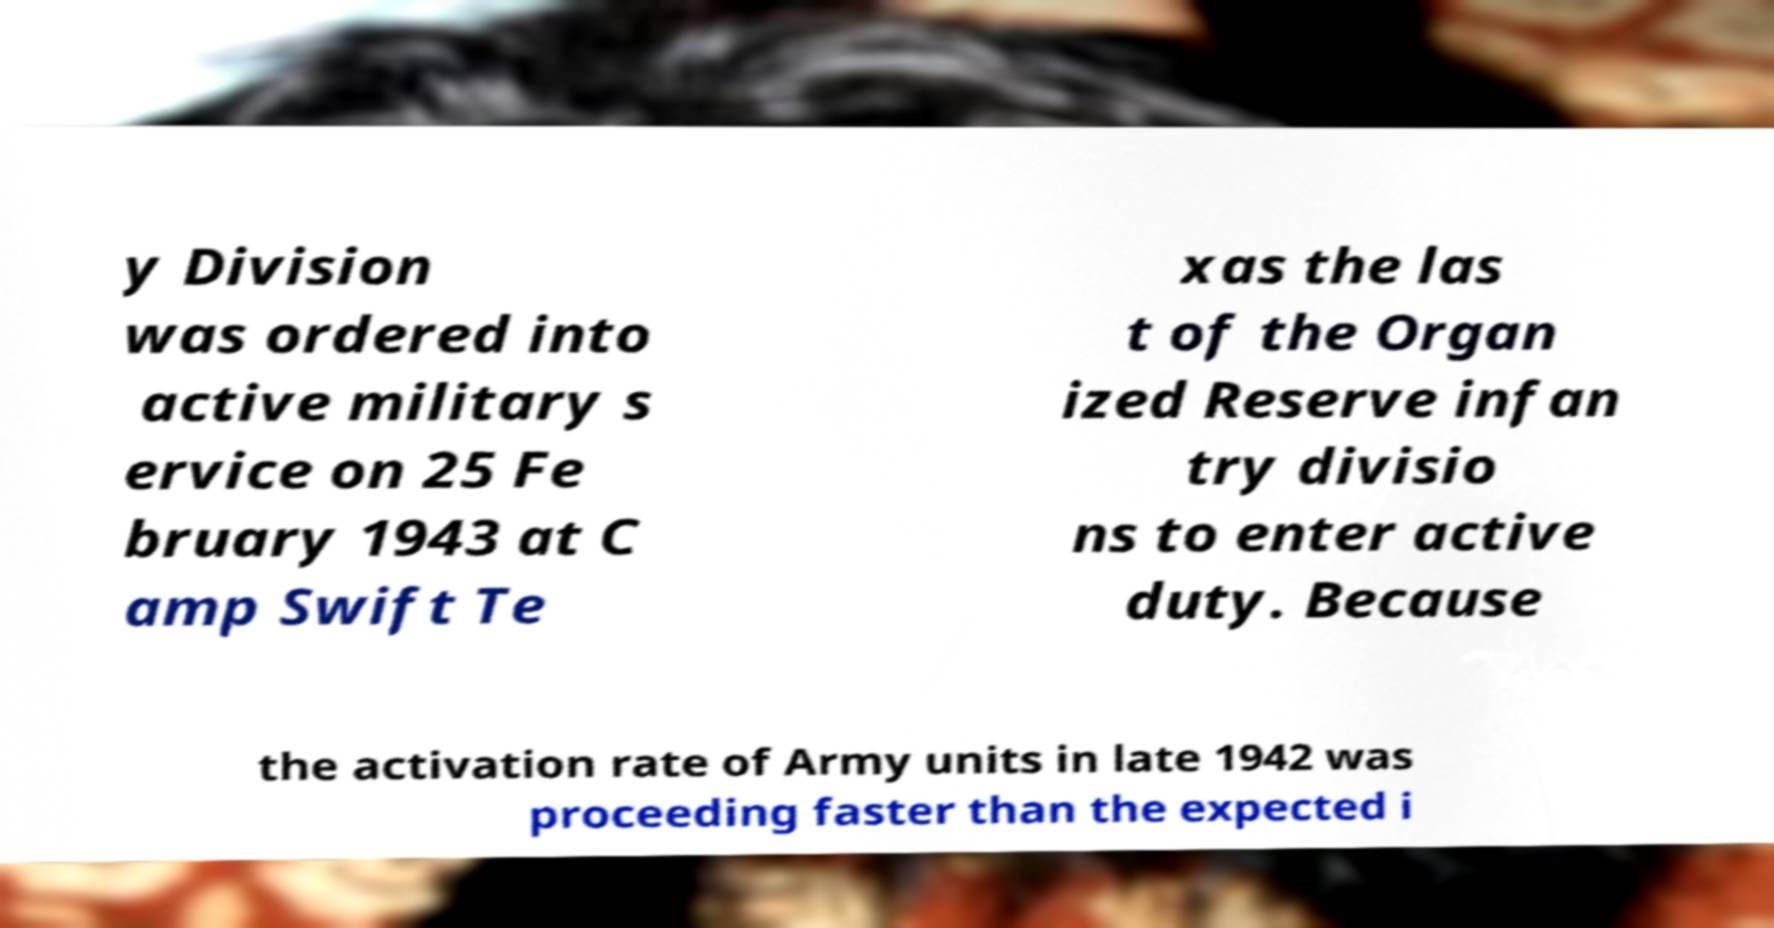Could you extract and type out the text from this image? y Division was ordered into active military s ervice on 25 Fe bruary 1943 at C amp Swift Te xas the las t of the Organ ized Reserve infan try divisio ns to enter active duty. Because the activation rate of Army units in late 1942 was proceeding faster than the expected i 